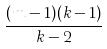Convert formula to latex. <formula><loc_0><loc_0><loc_500><loc_500>\frac { ( m - 1 ) ( k - 1 ) } { k - 2 }</formula> 